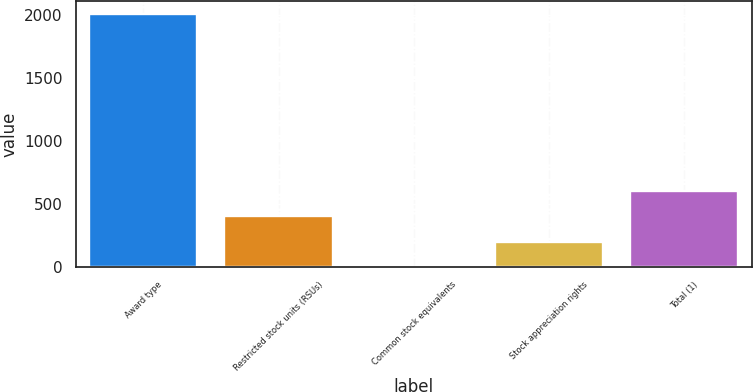<chart> <loc_0><loc_0><loc_500><loc_500><bar_chart><fcel>Award type<fcel>Restricted stock units (RSUs)<fcel>Common stock equivalents<fcel>Stock appreciation rights<fcel>Total (1)<nl><fcel>2009<fcel>402.12<fcel>0.4<fcel>201.26<fcel>602.98<nl></chart> 